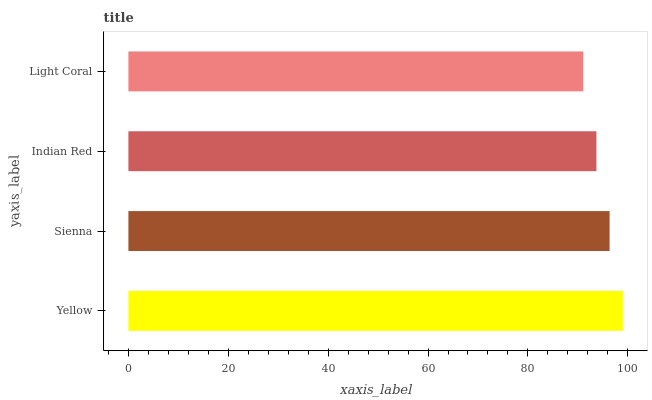Is Light Coral the minimum?
Answer yes or no. Yes. Is Yellow the maximum?
Answer yes or no. Yes. Is Sienna the minimum?
Answer yes or no. No. Is Sienna the maximum?
Answer yes or no. No. Is Yellow greater than Sienna?
Answer yes or no. Yes. Is Sienna less than Yellow?
Answer yes or no. Yes. Is Sienna greater than Yellow?
Answer yes or no. No. Is Yellow less than Sienna?
Answer yes or no. No. Is Sienna the high median?
Answer yes or no. Yes. Is Indian Red the low median?
Answer yes or no. Yes. Is Yellow the high median?
Answer yes or no. No. Is Sienna the low median?
Answer yes or no. No. 